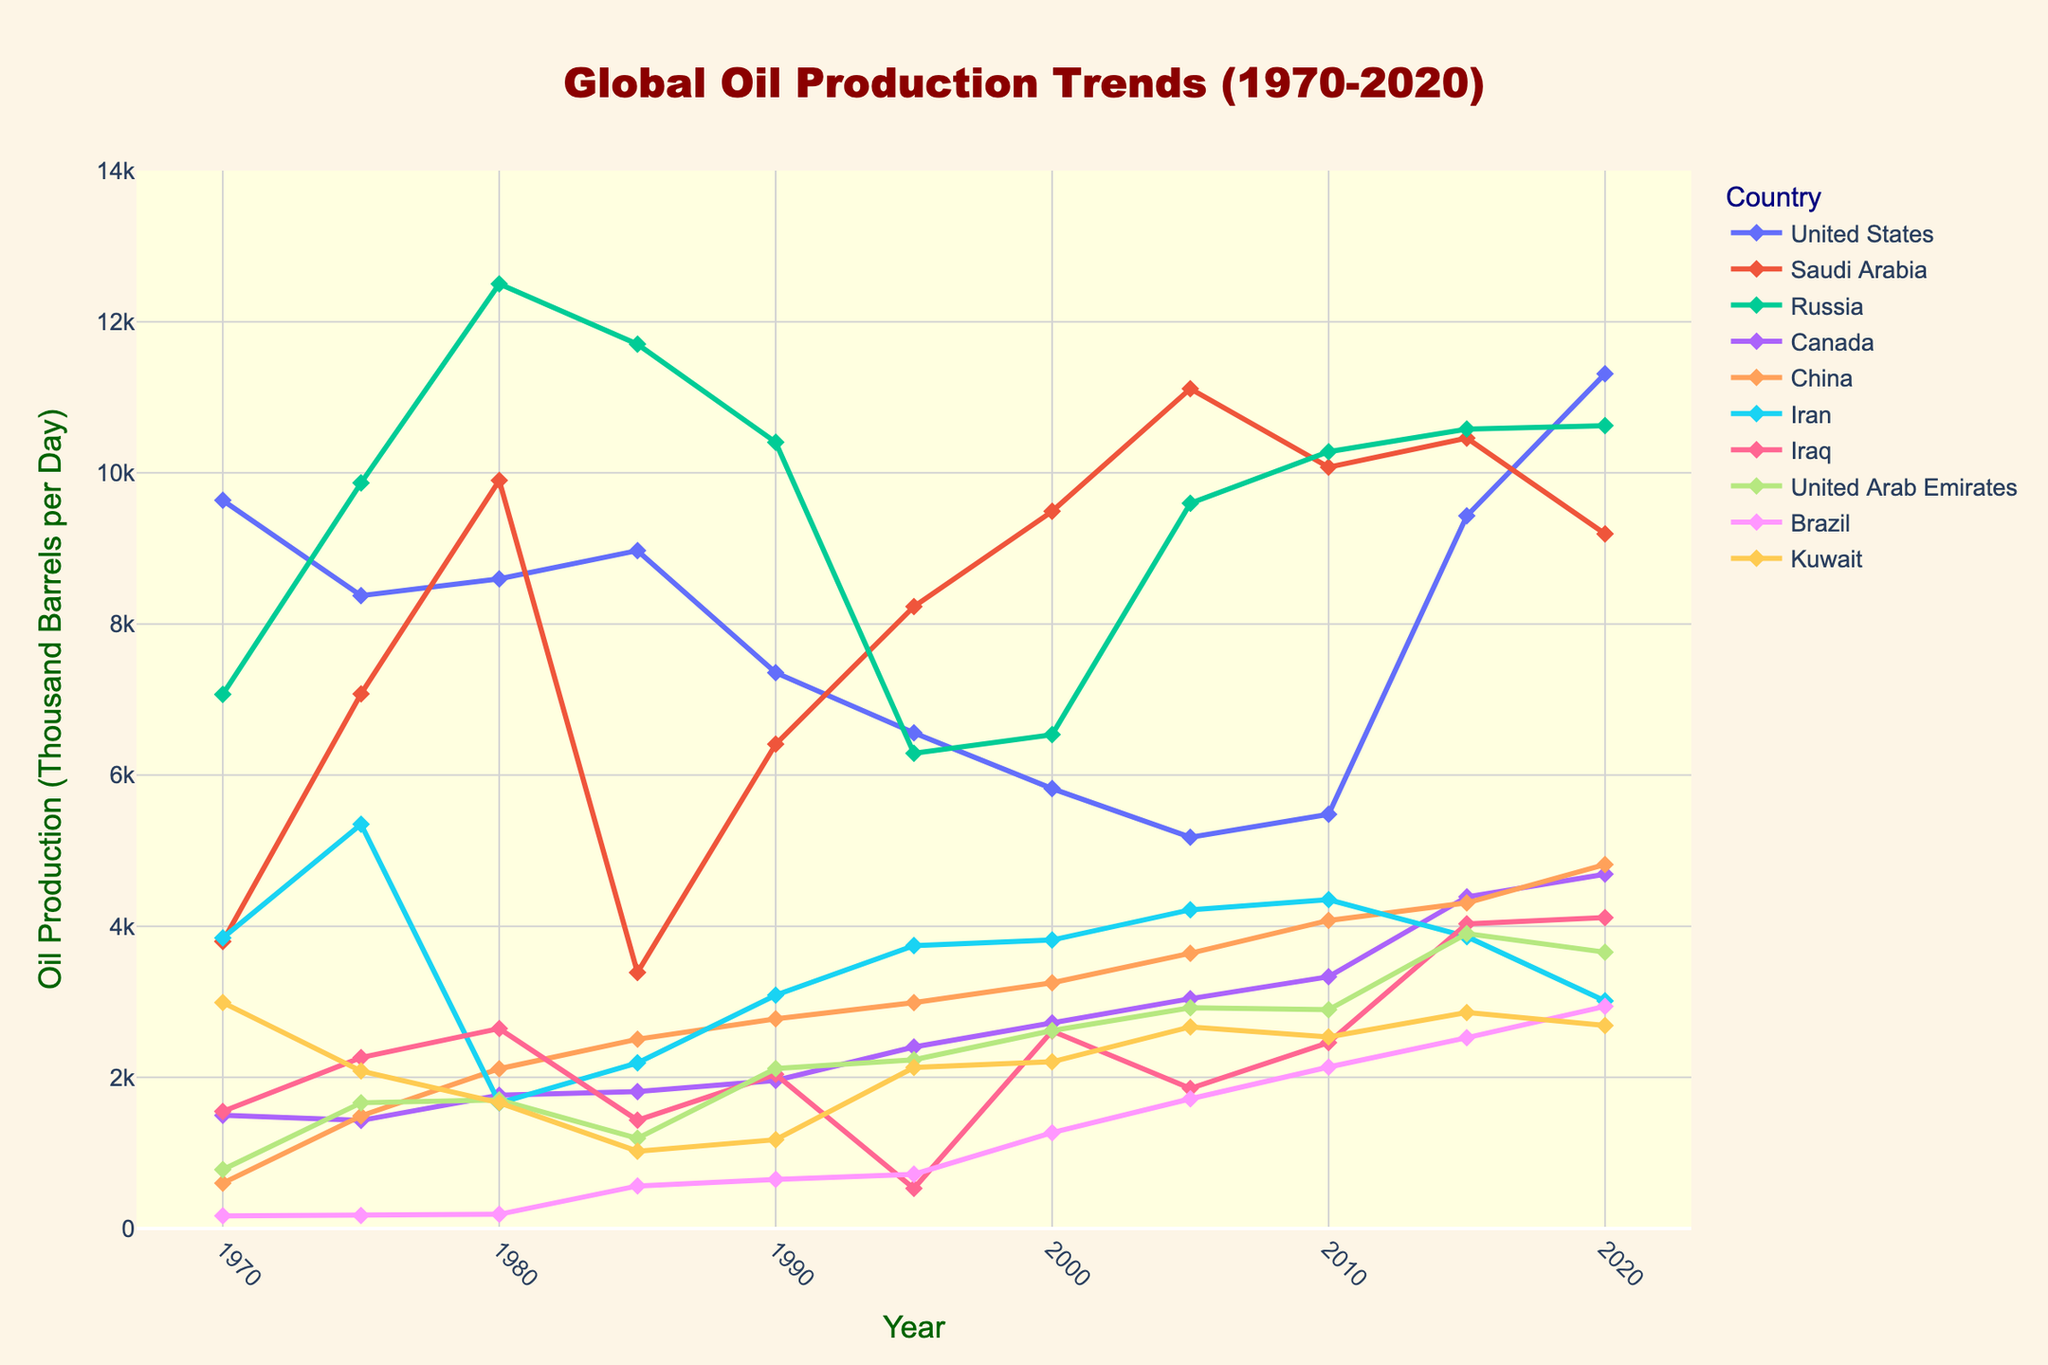What's the highest oil production figure for Saudi Arabia in the given period? Check the peaks along the Saudi Arabia line and select the maximum y-value. In 1980, the figure reached 9900 thousand barrels per day, which is the highest value for Saudi Arabia.
Answer: 9900 How did the oil production in Russia compare between 1970 and 2020? Look at the points for Russia in 1970 (7068) and 2020 (10625). Compare these two values directly. Russia's oil production increased from 7068 thousand barrels per day in 1970 to 10625 in 2020.
Answer: 7068 in 1970, 10625 in 2020 Which country had the lowest oil production in 1970, and what was the value? Scan the data points for 1970 across all countries and select the smallest one. Brazil had the lowest oil production in 1970, with a value of 167 thousand barrels per day.
Answer: Brazil, 167 Calculate the difference in oil production between the United States and Russia in 2015. Refer to the figure for 2015 values: United States = 9431, Russia = 10580. Subtract the value for the United States from Russia: 10580 - 9431 = 1149.
Answer: 1149 What trend can be observed for Canadian oil production from 1970 to 2020? Trace the line for Canada from 1970 to 2020. Canadian oil production shows a consistent upward trend, rising from 1498 in 1970 to 4689 thousand barrels per day in 2020.
Answer: Consistent upward trend Which year did Iraq's oil production exceed 4000 for the first time? Follow Iraq's line and find the first instance where it surpasses 4000. This happens in 2015, where production reaches 4031 thousand barrels per day.
Answer: 2015 Compare the change in oil production for China between 1990 and 2020. Check China's values in 1990 (2774) and 2020 (4816). Subtract 1990's production from 2020's: 4816 - 2774 = 2042.
Answer: Increased by 2042 Which country showed the most dramatic fluctuation in oil production over the 50 years and why? Observe the lines for all countries and identify which one appears the most volatile. The United States had significant fluctuations, with a notable drop from roughly 9637 in 1970 to around 5178 in 2005 and then a sharp increase to 11312 in 2020.
Answer: United States, dramatic fluctuations What is the average oil production for Kuwait across all years [1970-2020]? Sum all the values for Kuwait and then divide by the number of years. Sum = 2990 + 2084 + 1664 + 1023 + 1175 + 2130 + 2206 + 2668 + 2536 + 2858 + 2686 = 24020. Total years = 11. Average = 24020 / 11 = 2183.64
Answer: 2183.64 